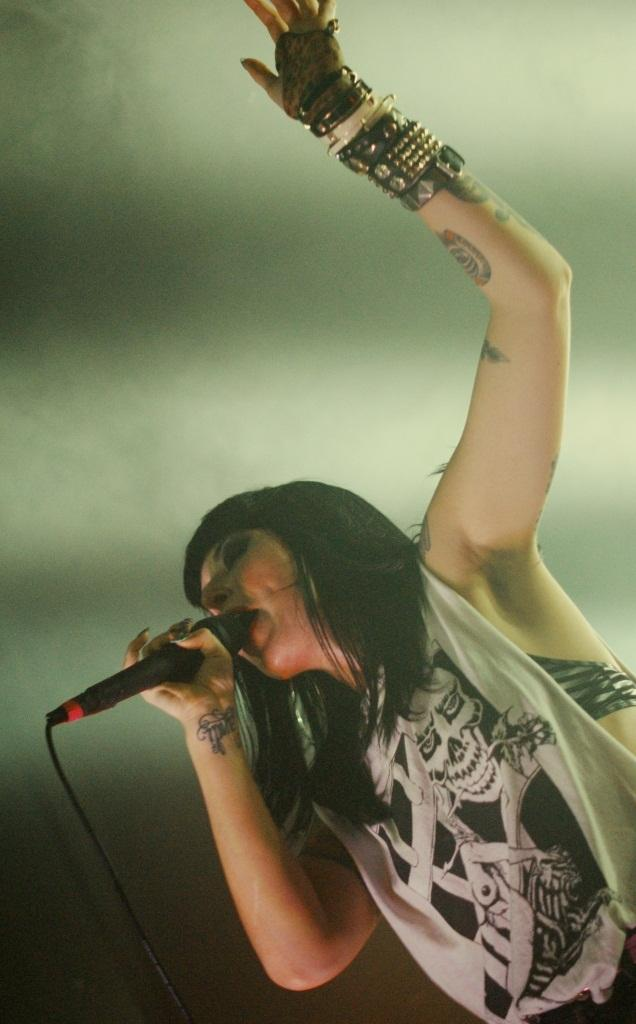Who is the main subject in the image? There is a woman in the image. What is the woman wearing? The woman is wearing a white dress. What object is the woman holding? The woman is holding a microphone. What is the woman doing in the image? The woman is singing. What type of creature can be seen swimming in the sea in the image? There is no sea or creature present in the image; it features a woman singing while holding a microphone. 